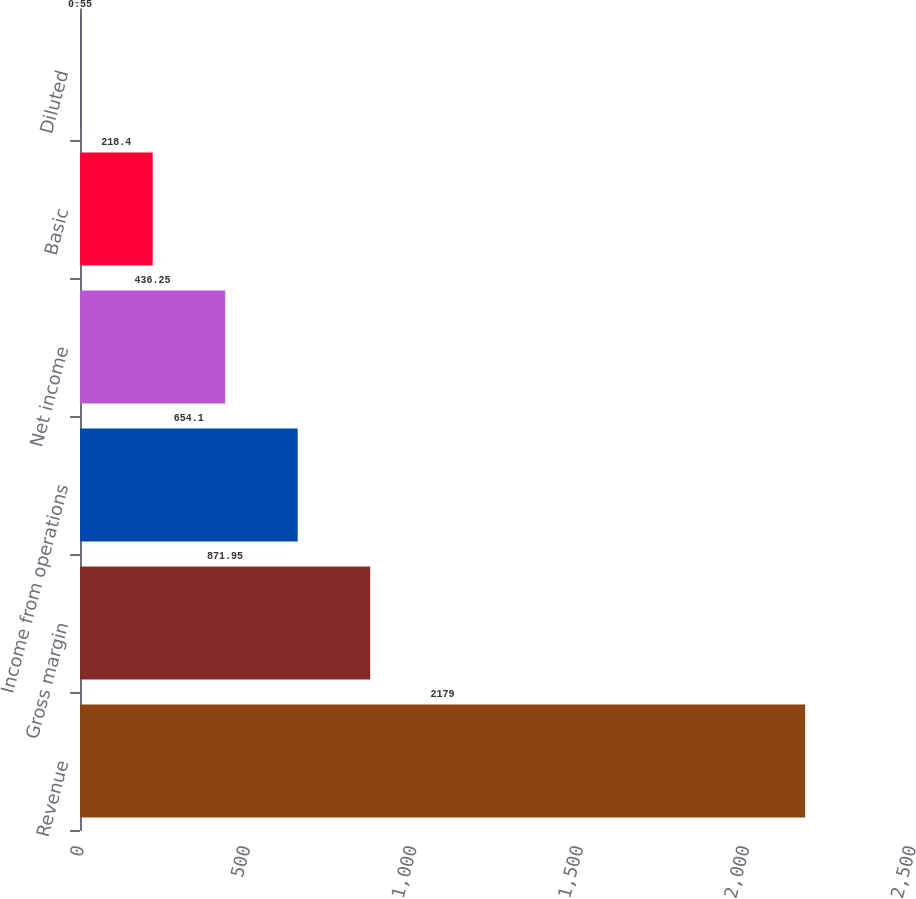Convert chart. <chart><loc_0><loc_0><loc_500><loc_500><bar_chart><fcel>Revenue<fcel>Gross margin<fcel>Income from operations<fcel>Net income<fcel>Basic<fcel>Diluted<nl><fcel>2179<fcel>871.95<fcel>654.1<fcel>436.25<fcel>218.4<fcel>0.55<nl></chart> 